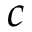Convert formula to latex. <formula><loc_0><loc_0><loc_500><loc_500>c</formula> 